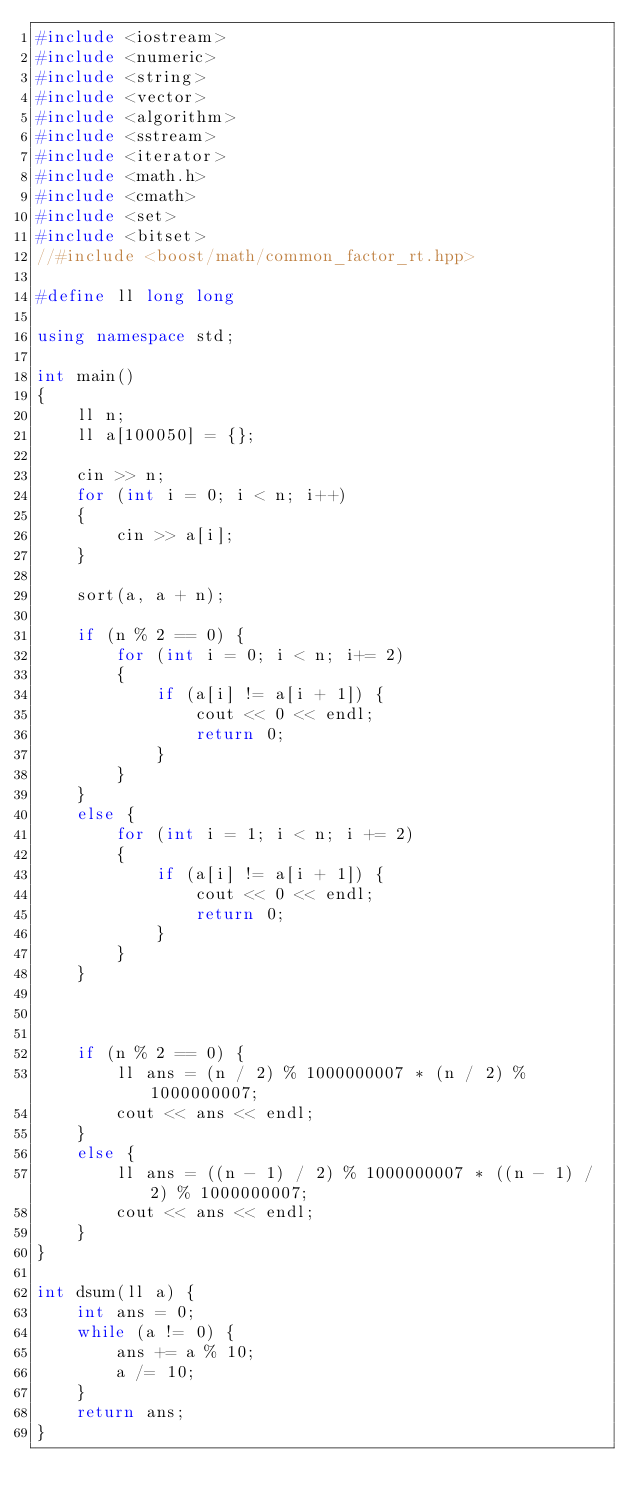Convert code to text. <code><loc_0><loc_0><loc_500><loc_500><_C++_>#include <iostream>
#include <numeric>
#include <string>
#include <vector>
#include <algorithm>
#include <sstream>
#include <iterator>
#include <math.h>
#include <cmath>
#include <set>   
#include <bitset>
//#include <boost/math/common_factor_rt.hpp>

#define ll long long

using namespace std;

int main()
{
	ll n;
	ll a[100050] = {};

	cin >> n;
	for (int i = 0; i < n; i++)
	{
		cin >> a[i];
	}
	
	sort(a, a + n);

	if (n % 2 == 0) {
		for (int i = 0; i < n; i+= 2)
		{
			if (a[i] != a[i + 1]) {
				cout << 0 << endl;
				return 0;
			}
		}
	}
	else {
		for (int i = 1; i < n; i += 2)
		{
			if (a[i] != a[i + 1]) {
				cout << 0 << endl;
				return 0;
			}
		}
	}

	

	if (n % 2 == 0) {
		ll ans = (n / 2) % 1000000007 * (n / 2) % 1000000007;
		cout << ans << endl;
	}
	else {
		ll ans = ((n - 1) / 2) % 1000000007 * ((n - 1) / 2) % 1000000007;
		cout << ans << endl;
	}
}

int dsum(ll a) {
	int ans = 0;
	while (a != 0) {
		ans += a % 10;
		a /= 10;
	}
	return ans;
}
</code> 